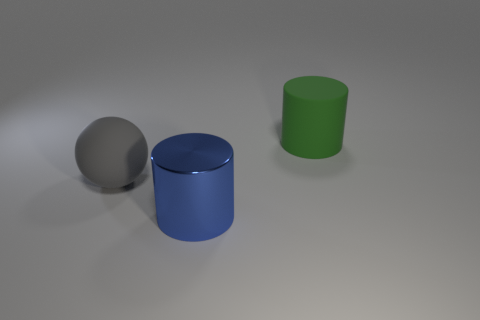What number of blue objects are either metallic objects or rubber things?
Provide a short and direct response. 1. What size is the green cylinder that is made of the same material as the big gray sphere?
Provide a succinct answer. Large. Is the big cylinder that is right of the large blue shiny cylinder made of the same material as the object left of the big blue metallic cylinder?
Ensure brevity in your answer.  Yes. How many spheres are gray matte objects or large metal objects?
Your answer should be very brief. 1. There is a object behind the large rubber object that is in front of the green rubber cylinder; how many green cylinders are to the left of it?
Your answer should be compact. 0. There is a blue object that is the same shape as the green thing; what is it made of?
Offer a terse response. Metal. Is there anything else that has the same material as the large blue thing?
Offer a very short reply. No. What color is the object that is behind the big gray object?
Provide a succinct answer. Green. Does the large gray thing have the same material as the thing behind the sphere?
Your response must be concise. Yes. What is the sphere made of?
Ensure brevity in your answer.  Rubber. 